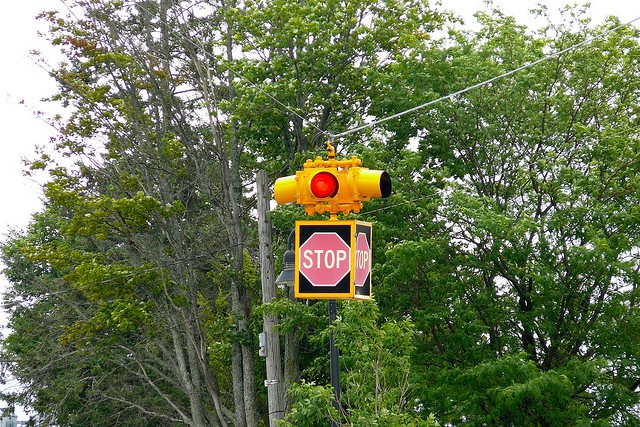Describe the objects in this image and their specific colors. I can see traffic light in white, orange, gold, and red tones, stop sign in white, salmon, beige, and lightpink tones, and stop sign in white, lightpink, salmon, and beige tones in this image. 